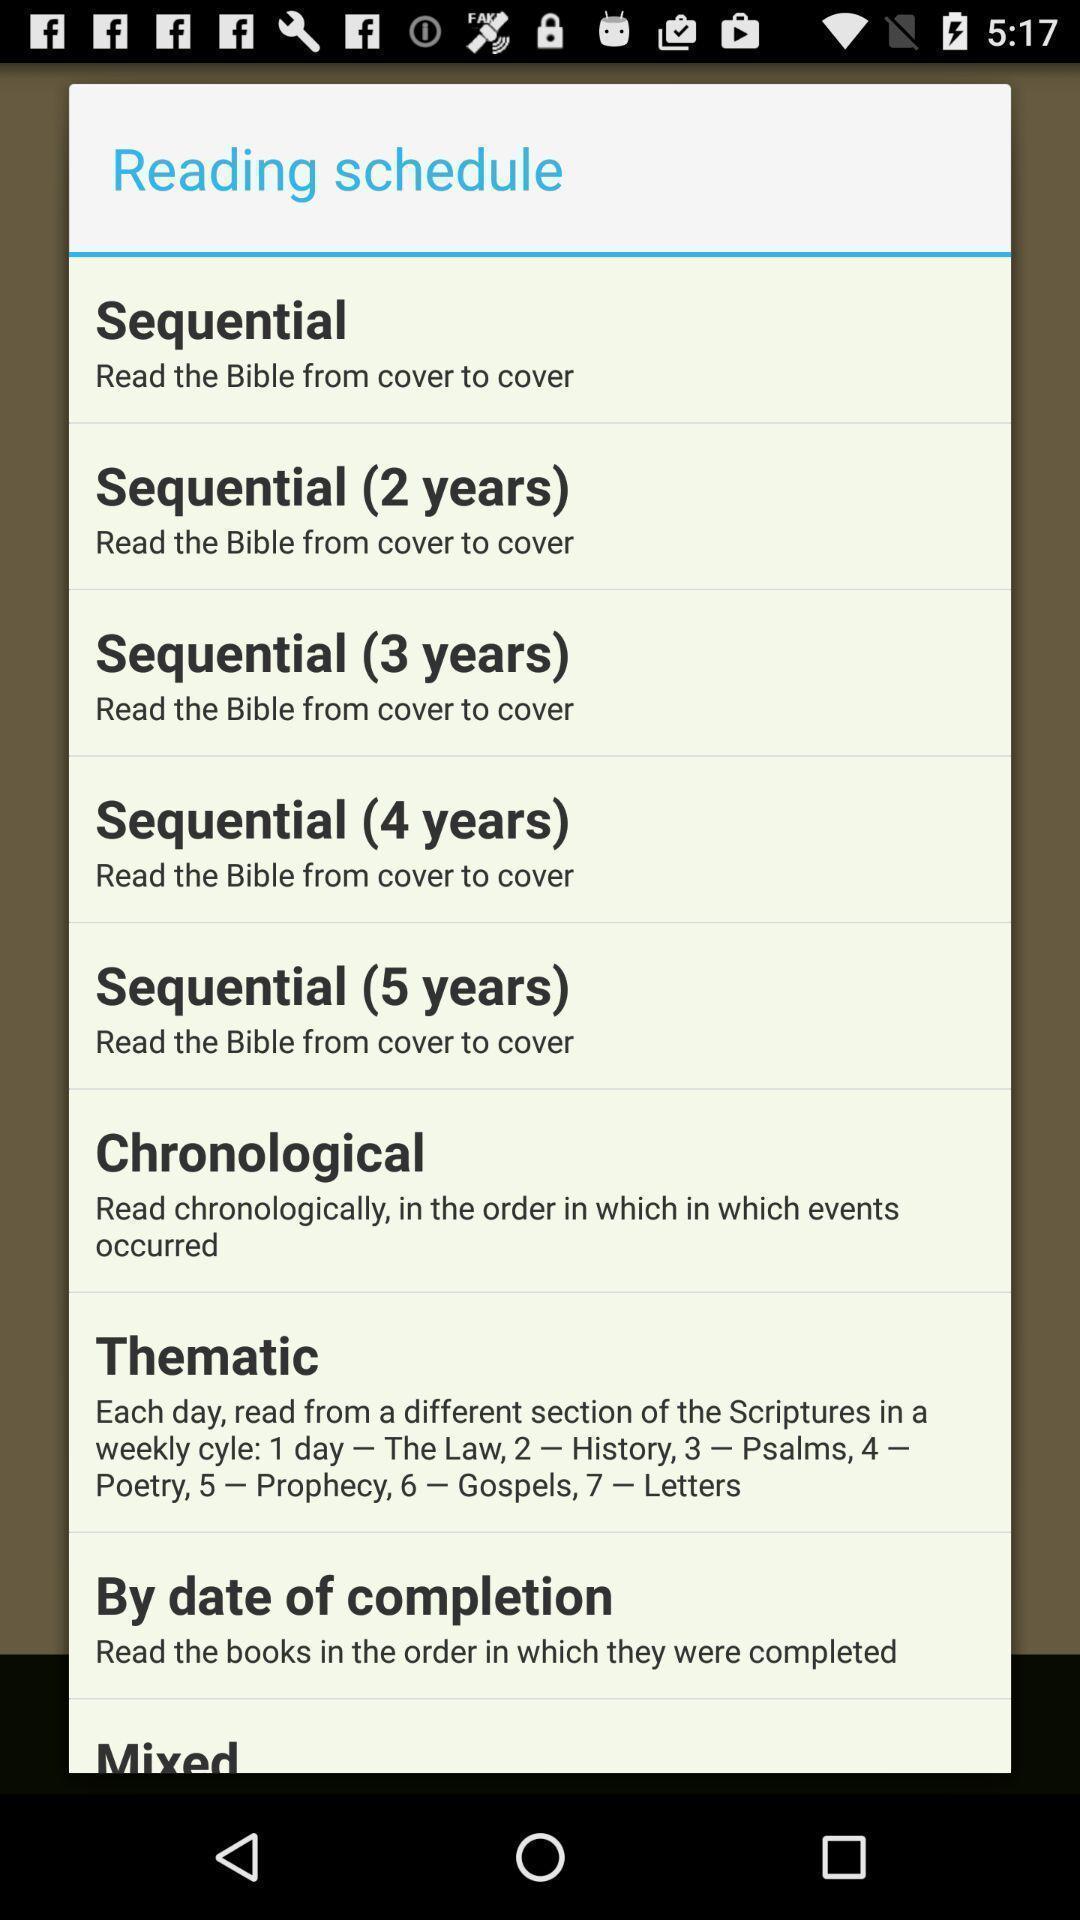Please provide a description for this image. Pop-up showing list of reading schedule. 